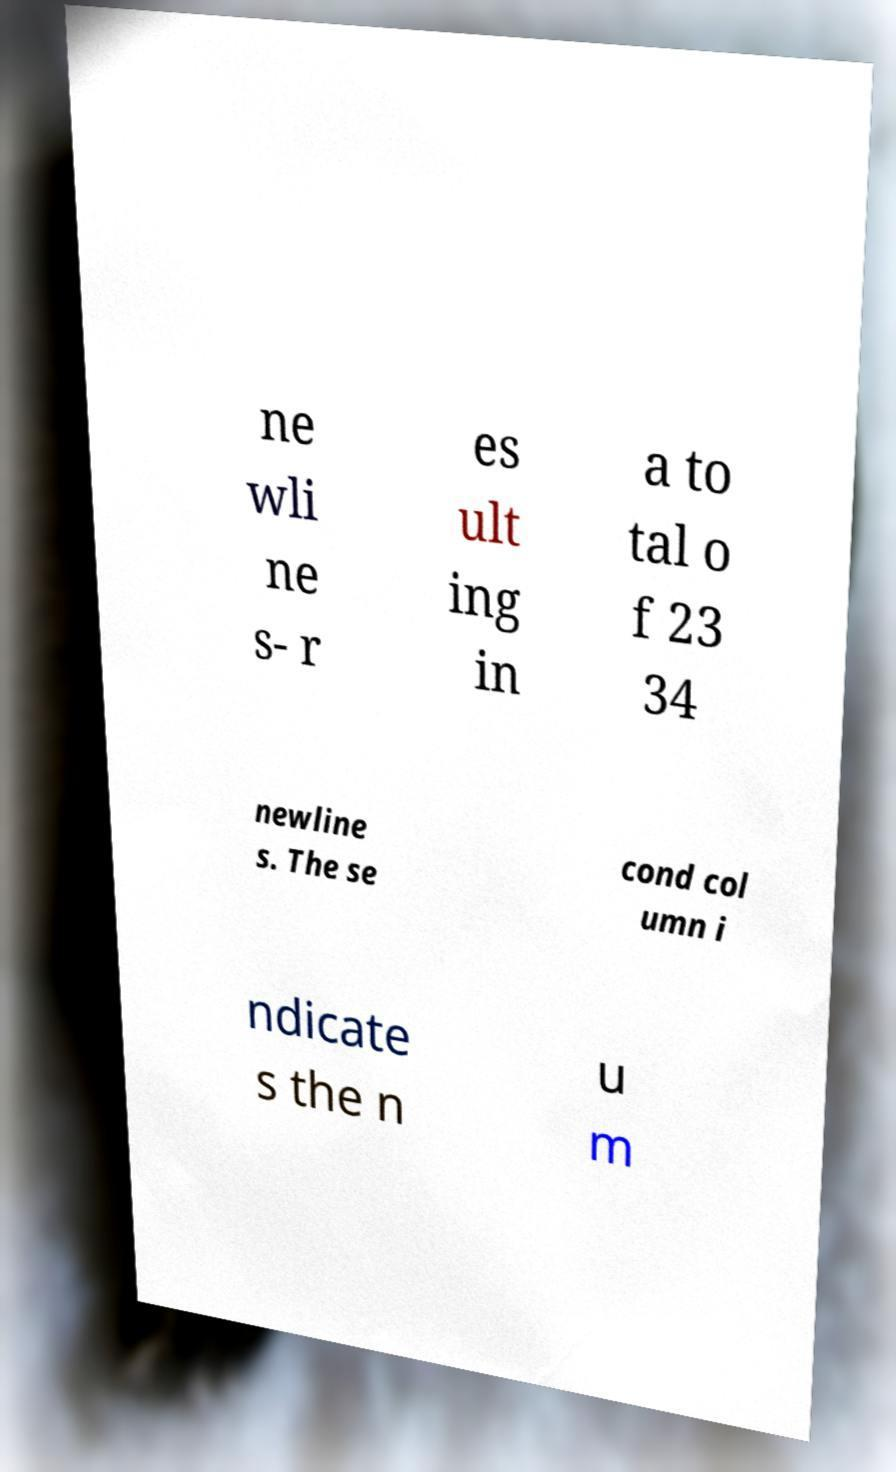What messages or text are displayed in this image? I need them in a readable, typed format. ne wli ne s- r es ult ing in a to tal o f 23 34 newline s. The se cond col umn i ndicate s the n u m 